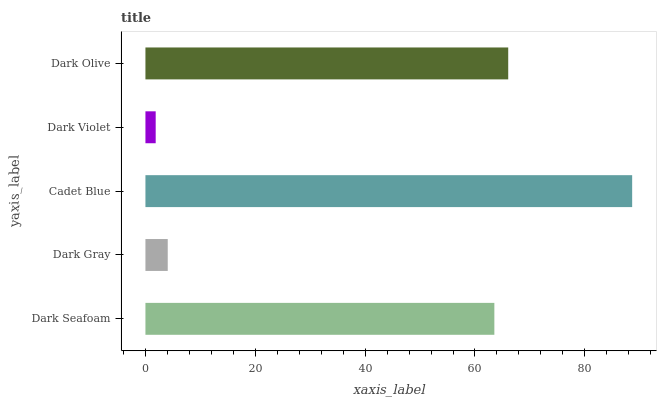Is Dark Violet the minimum?
Answer yes or no. Yes. Is Cadet Blue the maximum?
Answer yes or no. Yes. Is Dark Gray the minimum?
Answer yes or no. No. Is Dark Gray the maximum?
Answer yes or no. No. Is Dark Seafoam greater than Dark Gray?
Answer yes or no. Yes. Is Dark Gray less than Dark Seafoam?
Answer yes or no. Yes. Is Dark Gray greater than Dark Seafoam?
Answer yes or no. No. Is Dark Seafoam less than Dark Gray?
Answer yes or no. No. Is Dark Seafoam the high median?
Answer yes or no. Yes. Is Dark Seafoam the low median?
Answer yes or no. Yes. Is Dark Olive the high median?
Answer yes or no. No. Is Dark Violet the low median?
Answer yes or no. No. 